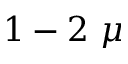Convert formula to latex. <formula><loc_0><loc_0><loc_500><loc_500>1 - 2 \mu</formula> 